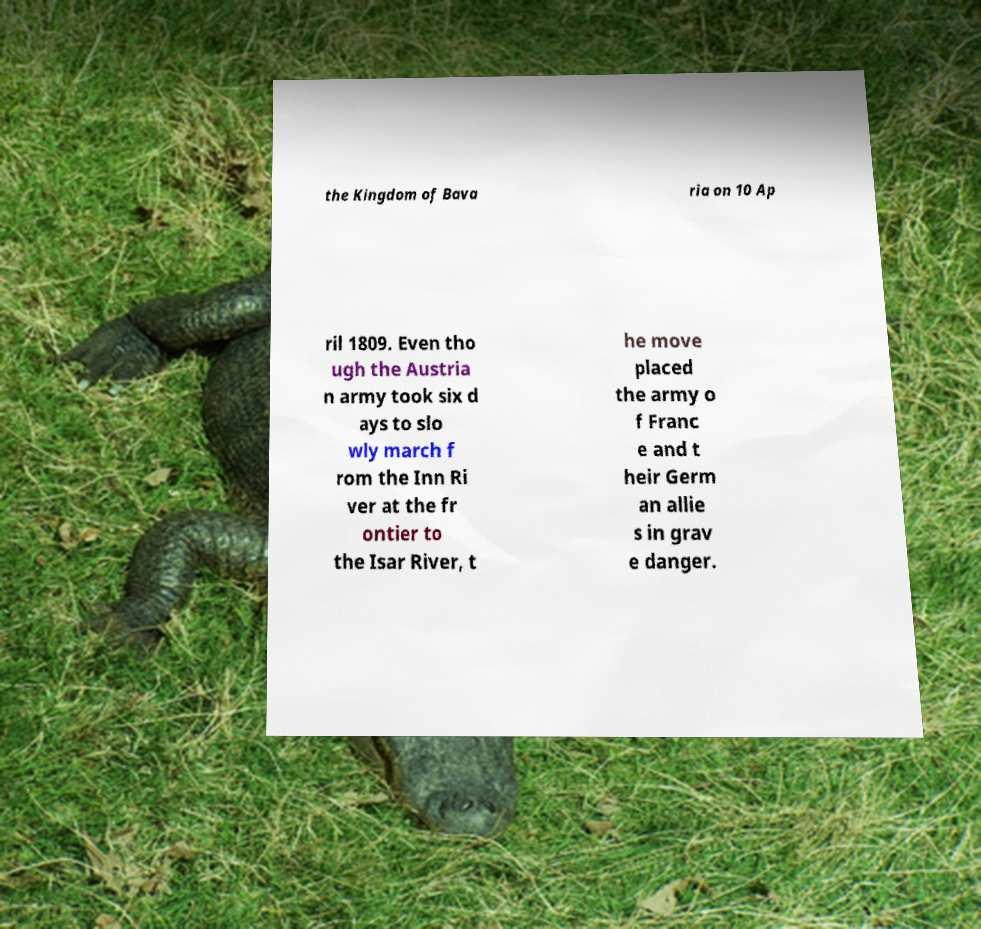Could you extract and type out the text from this image? the Kingdom of Bava ria on 10 Ap ril 1809. Even tho ugh the Austria n army took six d ays to slo wly march f rom the Inn Ri ver at the fr ontier to the Isar River, t he move placed the army o f Franc e and t heir Germ an allie s in grav e danger. 